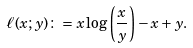<formula> <loc_0><loc_0><loc_500><loc_500>\ell ( x ; y ) \colon = x \log \left ( \frac { x } { y } \right ) - x + y .</formula> 